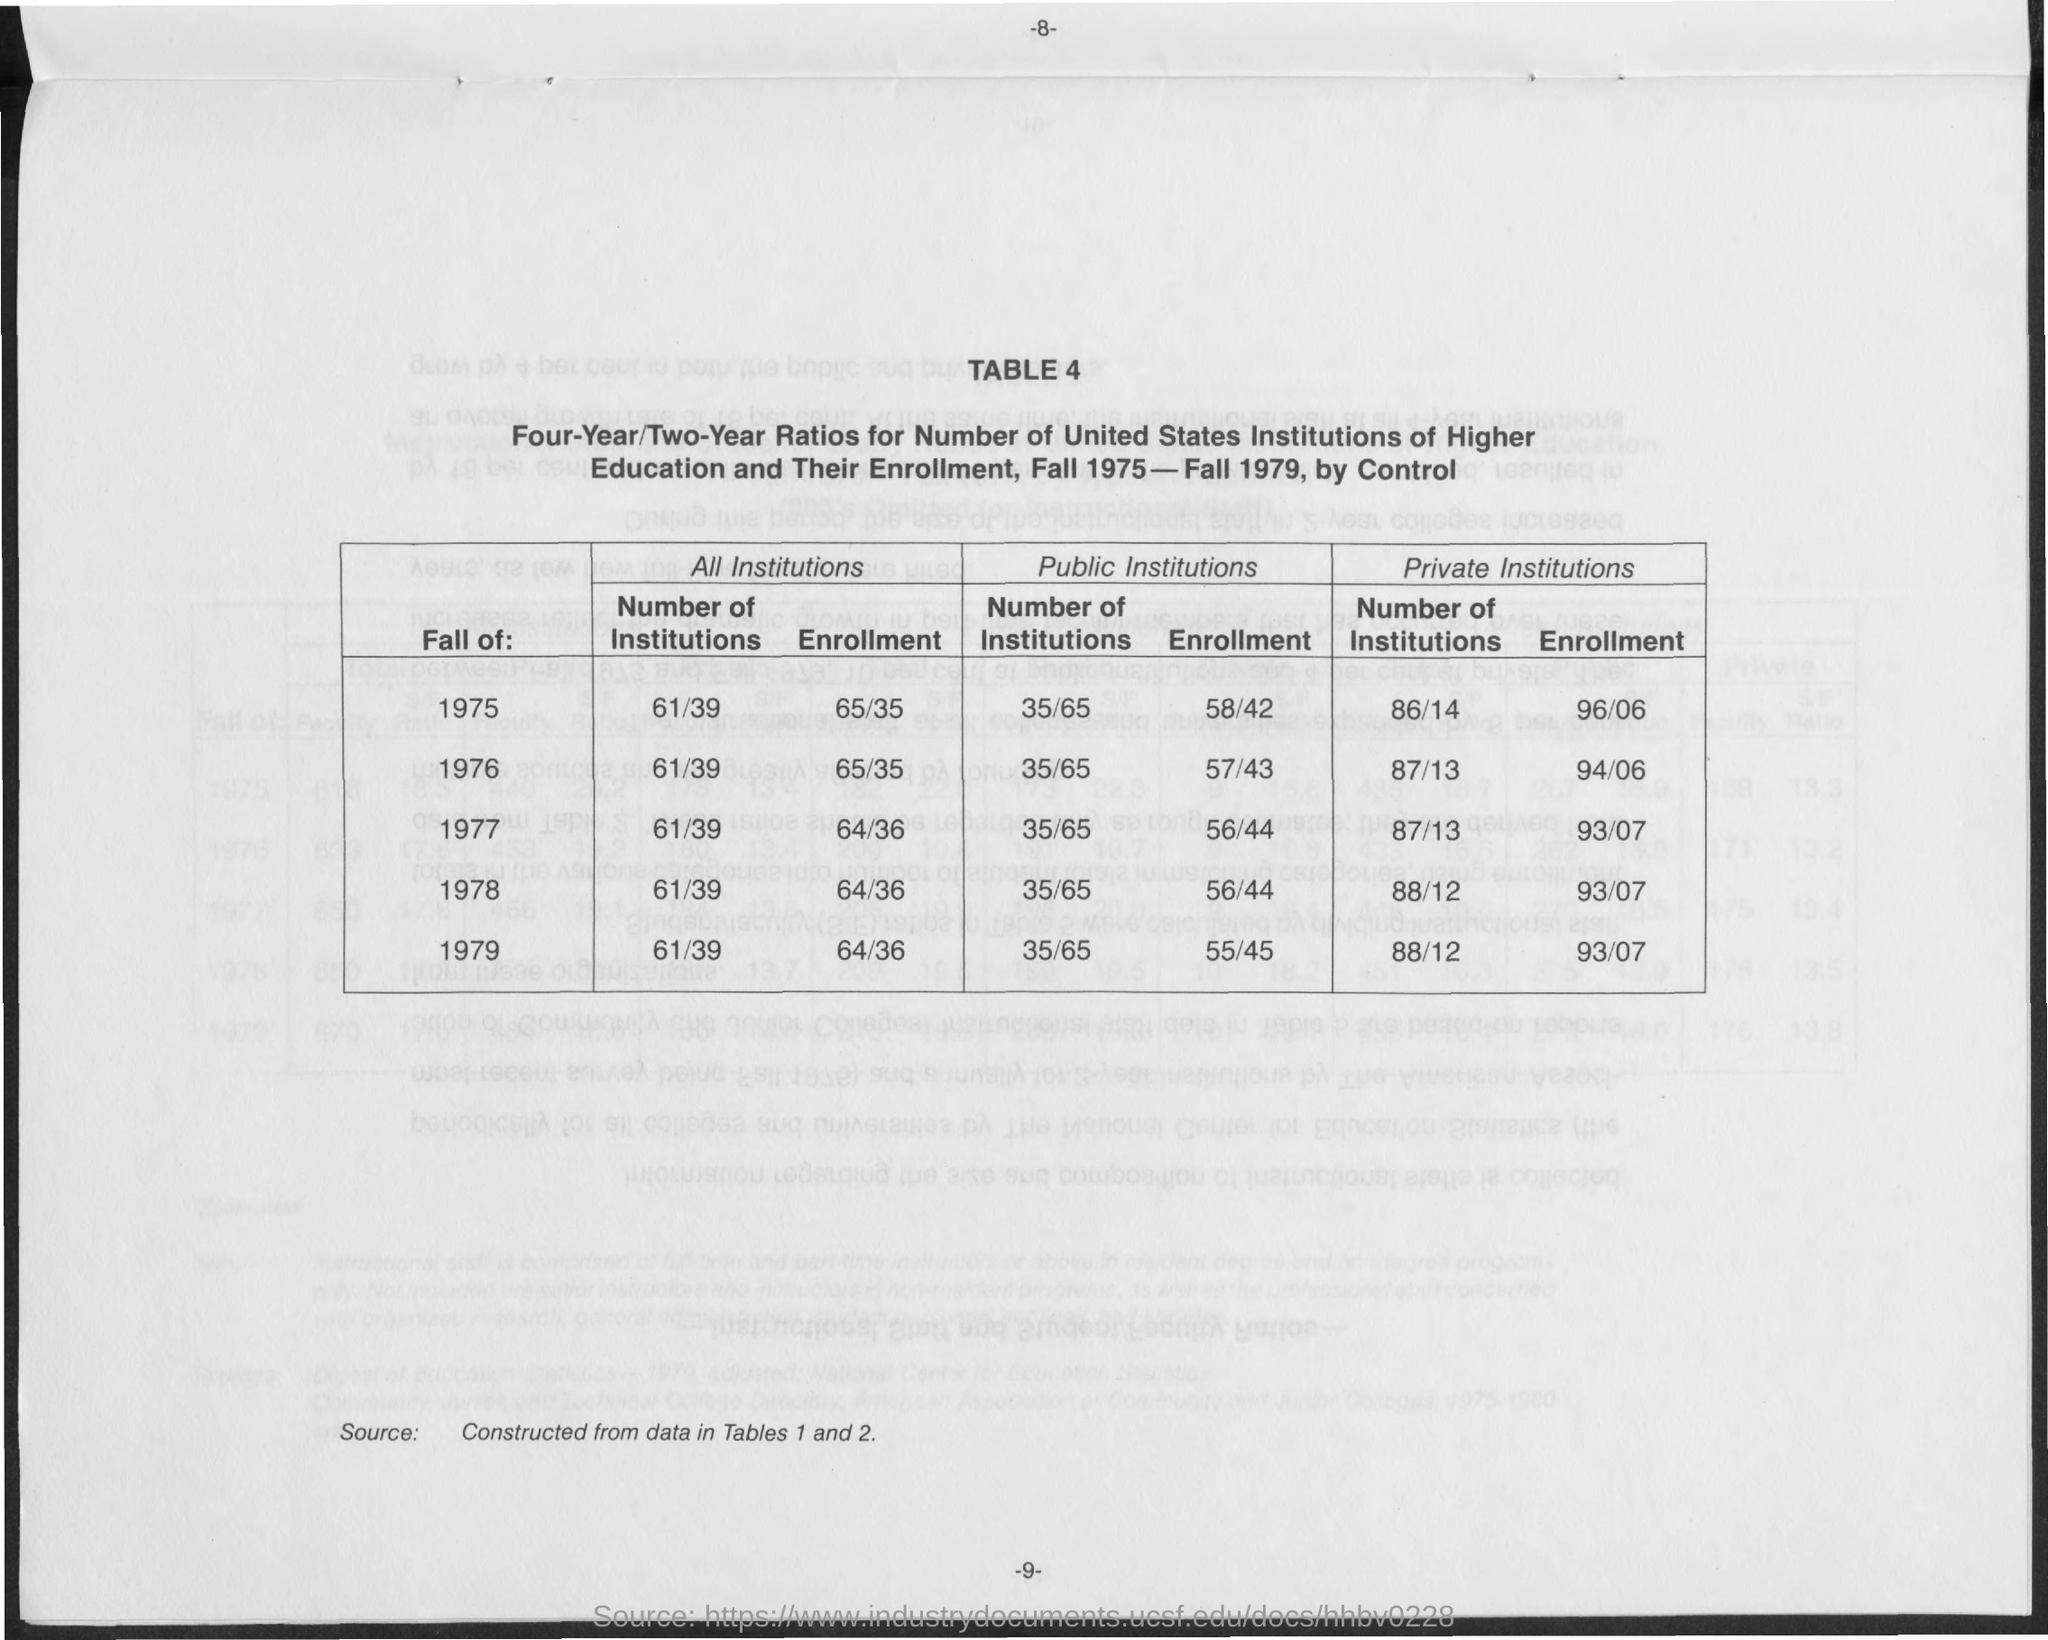What is the "TABLE" number?
Make the answer very short. 4. What is the "Four-Year/Two Year Ratio" of " Number of Institutions" under "All Instititions" during 1975?
Provide a succinct answer. 61/39. What is the "Four-Year/Two Year Ratio" of " Number of Institutions" under "All Instititions" during 1979?
Give a very brief answer. 61/39. What is the "Four-Year/Two Year Ratio" of  "Enrollment" under "All Instititions" during 1979?
Your response must be concise. 64/36. What is the "Four-Year/Two Year Ratio" of "Enrollment" under "All Instititions" during 1976?
Ensure brevity in your answer.  65/35. What is the "Four-Year/Two Year Ratio" of " Number of Institutions" under "Public Instititions" during 1978?
Ensure brevity in your answer.  35/65. What is the "Four-Year/Two Year Ratio" of " Enrollment" under "Public Instititions" during 1978?
Your answer should be very brief. 56/44. What is the "Four-Year/Two Year Ratio" of " Enrollment" under "Public Instititions" during 1975?
Keep it short and to the point. 58/42. What is the "Four-Year/Two Year Ratio" of " Number of Institutions" under "Private Instititions" during 1978?
Offer a very short reply. 88/12. TABLE 4 is "Constructed from data in" which all tables?
Offer a very short reply. Tables 1 and 2. 